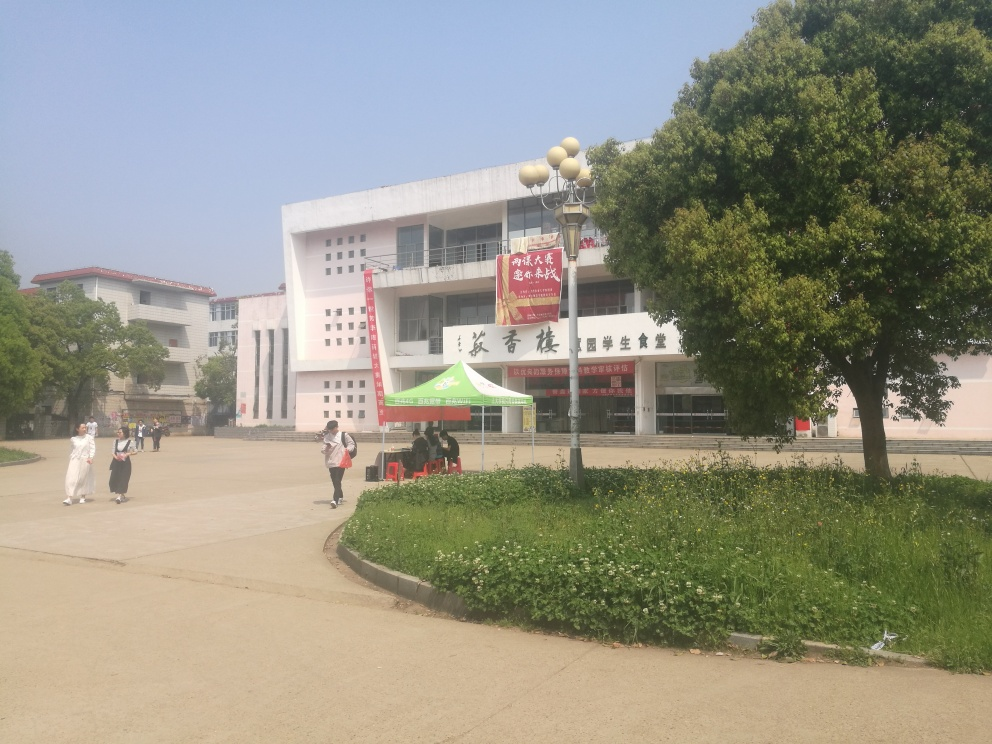What activities can you infer are happening in this location? Observing the individuals in the image, it looks like a few people are walking and another is poised as if taking a break or waiting for someone. The presence of a canopy tent indicates that there might be an outdoor event or activity, possibly related to the banners displayed on the building. Could you tell me more about the likely time of year or season this photo was taken? Given the lush greenery of the trees and the attire of the individuals, which appears light and suitable for warmer weather, it is plausible that the photo was taken in late spring or early summer. The clear skies and bright sunlight further support this estimation of the season. 